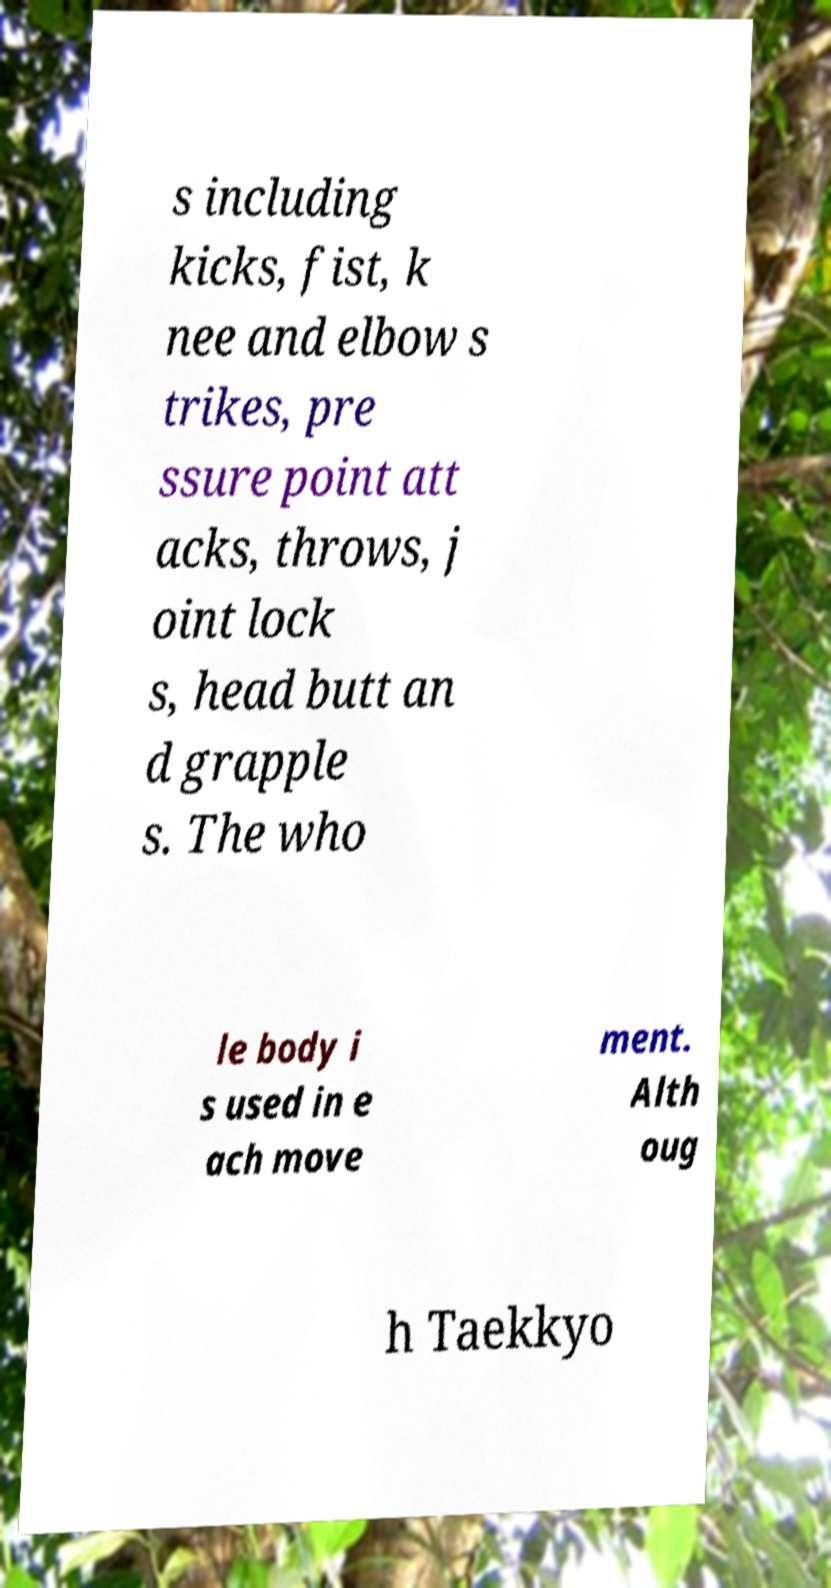Can you read and provide the text displayed in the image?This photo seems to have some interesting text. Can you extract and type it out for me? s including kicks, fist, k nee and elbow s trikes, pre ssure point att acks, throws, j oint lock s, head butt an d grapple s. The who le body i s used in e ach move ment. Alth oug h Taekkyo 